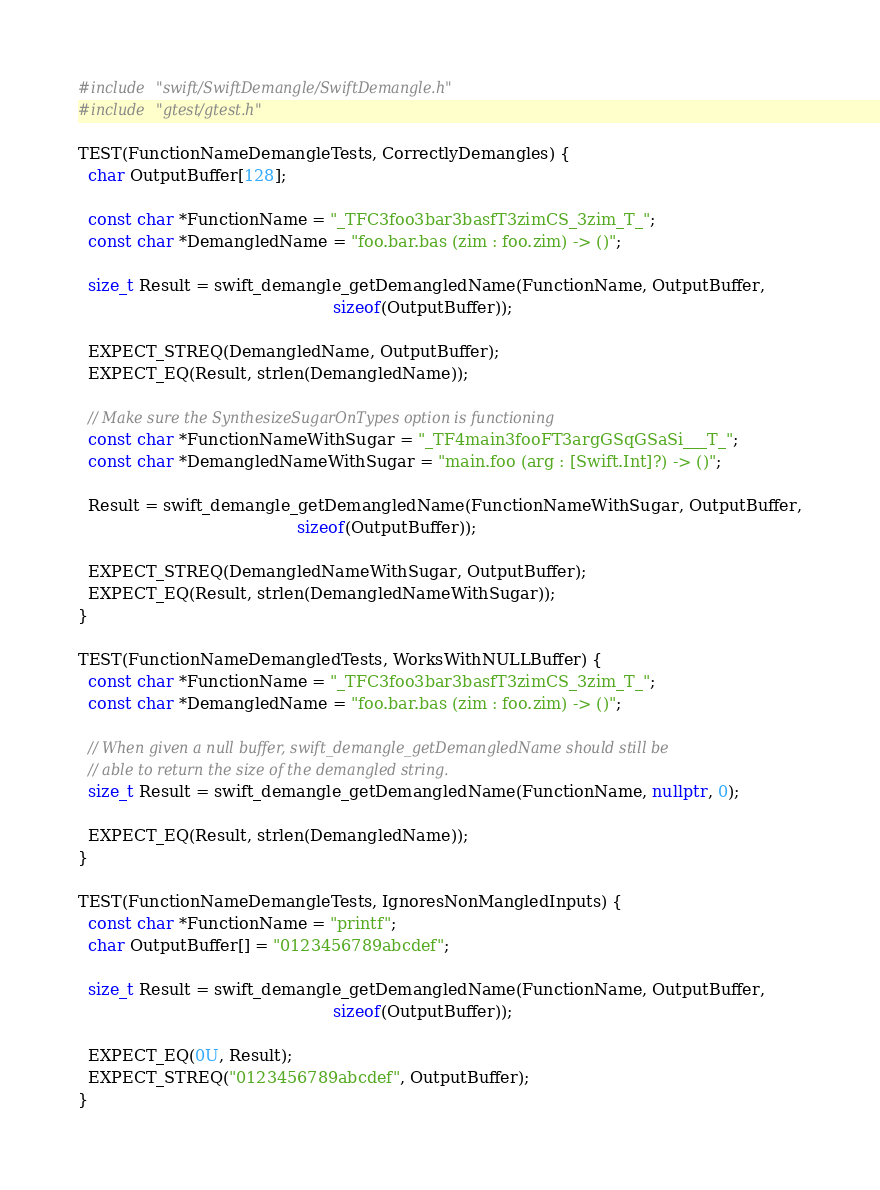Convert code to text. <code><loc_0><loc_0><loc_500><loc_500><_C++_>#include "swift/SwiftDemangle/SwiftDemangle.h"
#include "gtest/gtest.h"

TEST(FunctionNameDemangleTests, CorrectlyDemangles) {
  char OutputBuffer[128];

  const char *FunctionName = "_TFC3foo3bar3basfT3zimCS_3zim_T_";
  const char *DemangledName = "foo.bar.bas (zim : foo.zim) -> ()";

  size_t Result = swift_demangle_getDemangledName(FunctionName, OutputBuffer,
                                                  sizeof(OutputBuffer));

  EXPECT_STREQ(DemangledName, OutputBuffer);
  EXPECT_EQ(Result, strlen(DemangledName));

  // Make sure the SynthesizeSugarOnTypes option is functioning
  const char *FunctionNameWithSugar = "_TF4main3fooFT3argGSqGSaSi___T_";
  const char *DemangledNameWithSugar = "main.foo (arg : [Swift.Int]?) -> ()";

  Result = swift_demangle_getDemangledName(FunctionNameWithSugar, OutputBuffer,
                                           sizeof(OutputBuffer));

  EXPECT_STREQ(DemangledNameWithSugar, OutputBuffer);
  EXPECT_EQ(Result, strlen(DemangledNameWithSugar));
}

TEST(FunctionNameDemangledTests, WorksWithNULLBuffer) {
  const char *FunctionName = "_TFC3foo3bar3basfT3zimCS_3zim_T_";
  const char *DemangledName = "foo.bar.bas (zim : foo.zim) -> ()";

  // When given a null buffer, swift_demangle_getDemangledName should still be
  // able to return the size of the demangled string.
  size_t Result = swift_demangle_getDemangledName(FunctionName, nullptr, 0);

  EXPECT_EQ(Result, strlen(DemangledName));
}

TEST(FunctionNameDemangleTests, IgnoresNonMangledInputs) {
  const char *FunctionName = "printf";
  char OutputBuffer[] = "0123456789abcdef";

  size_t Result = swift_demangle_getDemangledName(FunctionName, OutputBuffer,
                                                  sizeof(OutputBuffer));

  EXPECT_EQ(0U, Result);
  EXPECT_STREQ("0123456789abcdef", OutputBuffer);
}

</code> 